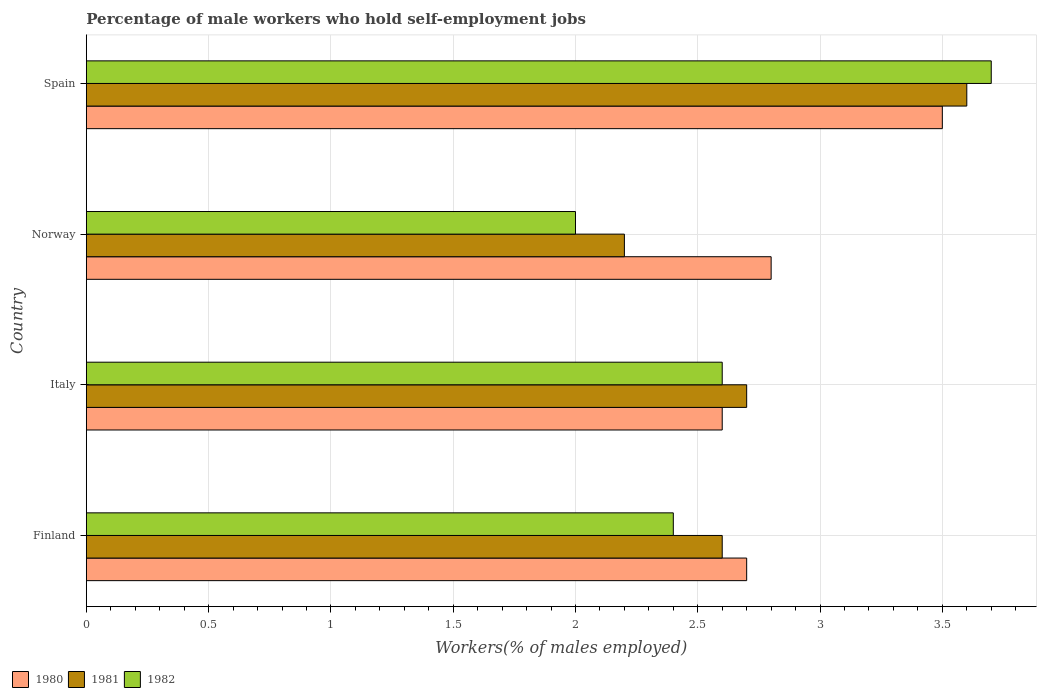How many different coloured bars are there?
Give a very brief answer. 3. Are the number of bars per tick equal to the number of legend labels?
Provide a short and direct response. Yes. How many bars are there on the 3rd tick from the top?
Give a very brief answer. 3. Across all countries, what is the maximum percentage of self-employed male workers in 1982?
Keep it short and to the point. 3.7. In which country was the percentage of self-employed male workers in 1982 maximum?
Provide a succinct answer. Spain. In which country was the percentage of self-employed male workers in 1981 minimum?
Your answer should be compact. Norway. What is the total percentage of self-employed male workers in 1982 in the graph?
Keep it short and to the point. 10.7. What is the difference between the percentage of self-employed male workers in 1982 in Norway and that in Spain?
Your answer should be compact. -1.7. What is the difference between the percentage of self-employed male workers in 1981 in Spain and the percentage of self-employed male workers in 1982 in Finland?
Provide a succinct answer. 1.2. What is the average percentage of self-employed male workers in 1981 per country?
Provide a short and direct response. 2.77. What is the difference between the percentage of self-employed male workers in 1981 and percentage of self-employed male workers in 1982 in Norway?
Your response must be concise. 0.2. In how many countries, is the percentage of self-employed male workers in 1981 greater than 0.4 %?
Your answer should be compact. 4. What is the ratio of the percentage of self-employed male workers in 1981 in Finland to that in Norway?
Ensure brevity in your answer.  1.18. Is the difference between the percentage of self-employed male workers in 1981 in Norway and Spain greater than the difference between the percentage of self-employed male workers in 1982 in Norway and Spain?
Offer a very short reply. Yes. What is the difference between the highest and the second highest percentage of self-employed male workers in 1982?
Your response must be concise. 1.1. What is the difference between the highest and the lowest percentage of self-employed male workers in 1982?
Your response must be concise. 1.7. In how many countries, is the percentage of self-employed male workers in 1981 greater than the average percentage of self-employed male workers in 1981 taken over all countries?
Make the answer very short. 1. What does the 2nd bar from the bottom in Italy represents?
Offer a very short reply. 1981. How many bars are there?
Make the answer very short. 12. What is the difference between two consecutive major ticks on the X-axis?
Give a very brief answer. 0.5. Are the values on the major ticks of X-axis written in scientific E-notation?
Make the answer very short. No. How many legend labels are there?
Provide a succinct answer. 3. How are the legend labels stacked?
Your response must be concise. Horizontal. What is the title of the graph?
Make the answer very short. Percentage of male workers who hold self-employment jobs. What is the label or title of the X-axis?
Offer a very short reply. Workers(% of males employed). What is the label or title of the Y-axis?
Your answer should be very brief. Country. What is the Workers(% of males employed) in 1980 in Finland?
Your answer should be compact. 2.7. What is the Workers(% of males employed) in 1981 in Finland?
Provide a short and direct response. 2.6. What is the Workers(% of males employed) in 1982 in Finland?
Your answer should be compact. 2.4. What is the Workers(% of males employed) of 1980 in Italy?
Offer a terse response. 2.6. What is the Workers(% of males employed) of 1981 in Italy?
Make the answer very short. 2.7. What is the Workers(% of males employed) of 1982 in Italy?
Offer a terse response. 2.6. What is the Workers(% of males employed) in 1980 in Norway?
Offer a terse response. 2.8. What is the Workers(% of males employed) in 1981 in Norway?
Provide a succinct answer. 2.2. What is the Workers(% of males employed) of 1982 in Norway?
Make the answer very short. 2. What is the Workers(% of males employed) in 1981 in Spain?
Provide a short and direct response. 3.6. What is the Workers(% of males employed) of 1982 in Spain?
Provide a short and direct response. 3.7. Across all countries, what is the maximum Workers(% of males employed) in 1980?
Your response must be concise. 3.5. Across all countries, what is the maximum Workers(% of males employed) in 1981?
Give a very brief answer. 3.6. Across all countries, what is the maximum Workers(% of males employed) in 1982?
Offer a terse response. 3.7. Across all countries, what is the minimum Workers(% of males employed) in 1980?
Give a very brief answer. 2.6. Across all countries, what is the minimum Workers(% of males employed) in 1981?
Your response must be concise. 2.2. Across all countries, what is the minimum Workers(% of males employed) of 1982?
Provide a succinct answer. 2. What is the total Workers(% of males employed) of 1980 in the graph?
Provide a succinct answer. 11.6. What is the total Workers(% of males employed) of 1981 in the graph?
Offer a very short reply. 11.1. What is the difference between the Workers(% of males employed) of 1981 in Finland and that in Italy?
Give a very brief answer. -0.1. What is the difference between the Workers(% of males employed) of 1982 in Finland and that in Italy?
Give a very brief answer. -0.2. What is the difference between the Workers(% of males employed) in 1980 in Finland and that in Norway?
Make the answer very short. -0.1. What is the difference between the Workers(% of males employed) of 1981 in Finland and that in Norway?
Provide a short and direct response. 0.4. What is the difference between the Workers(% of males employed) of 1982 in Finland and that in Norway?
Your answer should be compact. 0.4. What is the difference between the Workers(% of males employed) in 1982 in Finland and that in Spain?
Your answer should be compact. -1.3. What is the difference between the Workers(% of males employed) in 1981 in Italy and that in Norway?
Offer a very short reply. 0.5. What is the difference between the Workers(% of males employed) of 1982 in Italy and that in Norway?
Keep it short and to the point. 0.6. What is the difference between the Workers(% of males employed) of 1982 in Norway and that in Spain?
Ensure brevity in your answer.  -1.7. What is the difference between the Workers(% of males employed) of 1980 in Finland and the Workers(% of males employed) of 1981 in Italy?
Your response must be concise. 0. What is the difference between the Workers(% of males employed) of 1980 in Finland and the Workers(% of males employed) of 1982 in Italy?
Your answer should be compact. 0.1. What is the difference between the Workers(% of males employed) in 1981 in Finland and the Workers(% of males employed) in 1982 in Italy?
Your answer should be compact. 0. What is the difference between the Workers(% of males employed) of 1980 in Finland and the Workers(% of males employed) of 1982 in Norway?
Ensure brevity in your answer.  0.7. What is the difference between the Workers(% of males employed) in 1981 in Italy and the Workers(% of males employed) in 1982 in Norway?
Give a very brief answer. 0.7. What is the difference between the Workers(% of males employed) in 1980 in Italy and the Workers(% of males employed) in 1981 in Spain?
Your response must be concise. -1. What is the difference between the Workers(% of males employed) of 1980 in Italy and the Workers(% of males employed) of 1982 in Spain?
Give a very brief answer. -1.1. What is the difference between the Workers(% of males employed) in 1981 in Italy and the Workers(% of males employed) in 1982 in Spain?
Your answer should be compact. -1. What is the average Workers(% of males employed) in 1980 per country?
Provide a short and direct response. 2.9. What is the average Workers(% of males employed) of 1981 per country?
Ensure brevity in your answer.  2.77. What is the average Workers(% of males employed) in 1982 per country?
Provide a short and direct response. 2.67. What is the difference between the Workers(% of males employed) of 1980 and Workers(% of males employed) of 1981 in Finland?
Offer a very short reply. 0.1. What is the difference between the Workers(% of males employed) of 1980 and Workers(% of males employed) of 1982 in Finland?
Offer a very short reply. 0.3. What is the difference between the Workers(% of males employed) of 1980 and Workers(% of males employed) of 1981 in Italy?
Make the answer very short. -0.1. What is the difference between the Workers(% of males employed) in 1981 and Workers(% of males employed) in 1982 in Italy?
Give a very brief answer. 0.1. What is the difference between the Workers(% of males employed) of 1980 and Workers(% of males employed) of 1981 in Norway?
Provide a succinct answer. 0.6. What is the difference between the Workers(% of males employed) in 1981 and Workers(% of males employed) in 1982 in Norway?
Provide a succinct answer. 0.2. What is the difference between the Workers(% of males employed) of 1980 and Workers(% of males employed) of 1982 in Spain?
Offer a very short reply. -0.2. What is the difference between the Workers(% of males employed) in 1981 and Workers(% of males employed) in 1982 in Spain?
Offer a terse response. -0.1. What is the ratio of the Workers(% of males employed) in 1982 in Finland to that in Italy?
Ensure brevity in your answer.  0.92. What is the ratio of the Workers(% of males employed) in 1981 in Finland to that in Norway?
Keep it short and to the point. 1.18. What is the ratio of the Workers(% of males employed) in 1980 in Finland to that in Spain?
Provide a succinct answer. 0.77. What is the ratio of the Workers(% of males employed) of 1981 in Finland to that in Spain?
Provide a succinct answer. 0.72. What is the ratio of the Workers(% of males employed) in 1982 in Finland to that in Spain?
Provide a short and direct response. 0.65. What is the ratio of the Workers(% of males employed) in 1980 in Italy to that in Norway?
Your answer should be compact. 0.93. What is the ratio of the Workers(% of males employed) of 1981 in Italy to that in Norway?
Provide a succinct answer. 1.23. What is the ratio of the Workers(% of males employed) of 1980 in Italy to that in Spain?
Your answer should be very brief. 0.74. What is the ratio of the Workers(% of males employed) in 1981 in Italy to that in Spain?
Offer a very short reply. 0.75. What is the ratio of the Workers(% of males employed) of 1982 in Italy to that in Spain?
Ensure brevity in your answer.  0.7. What is the ratio of the Workers(% of males employed) in 1981 in Norway to that in Spain?
Your response must be concise. 0.61. What is the ratio of the Workers(% of males employed) in 1982 in Norway to that in Spain?
Make the answer very short. 0.54. What is the difference between the highest and the second highest Workers(% of males employed) in 1981?
Give a very brief answer. 0.9. What is the difference between the highest and the second highest Workers(% of males employed) in 1982?
Keep it short and to the point. 1.1. What is the difference between the highest and the lowest Workers(% of males employed) in 1980?
Provide a short and direct response. 0.9. What is the difference between the highest and the lowest Workers(% of males employed) of 1982?
Offer a terse response. 1.7. 